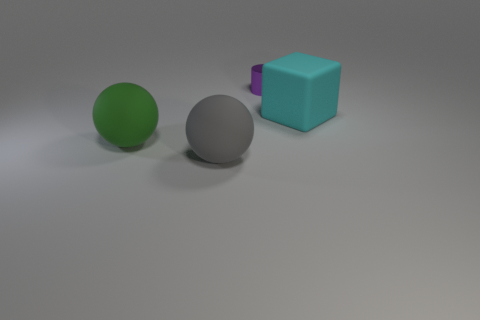Add 2 blue rubber cylinders. How many objects exist? 6 Subtract all cylinders. How many objects are left? 3 Subtract all big matte things. Subtract all tiny gray matte objects. How many objects are left? 1 Add 2 big rubber balls. How many big rubber balls are left? 4 Add 1 large gray objects. How many large gray objects exist? 2 Subtract 0 yellow cubes. How many objects are left? 4 